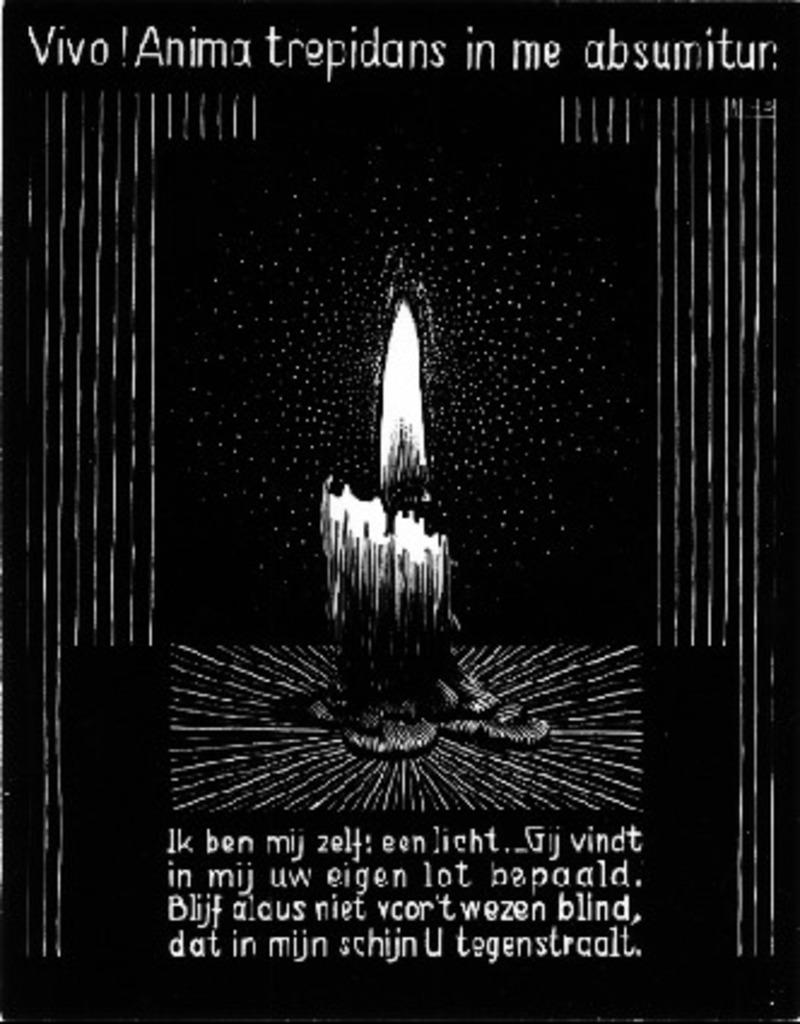What is the main subject of the image? The image contains the cover page of a book. Can you describe any specific details about the cover page? Unfortunately, the provided facts do not include any specific details about the cover page. How many words are written on the swing in the image? There is no swing present in the image, and therefore no words can be found on a swing. 